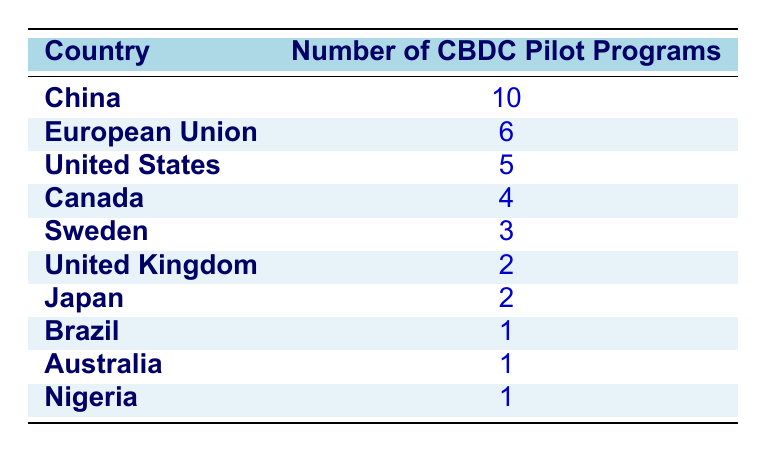What country has the most CBDC pilot programs? From the table, we can see that China has 10 pilot programs, which is the highest number listed.
Answer: China How many countries have more than 2 CBDC pilot programs? The countries with more than 2 pilot programs are China (10), European Union (6), and United States (5), totaling 3 countries.
Answer: 3 Does Canada have more CBDC pilot programs than Japan? Canada has 4 pilot programs and Japan has 2 pilot programs. Therefore, Canada does indeed have more pilot programs than Japan.
Answer: Yes What is the total number of CBDC pilot programs across all listed countries? To find the total, we sum the number of pilot programs: 10 (China) + 5 (United States) + 6 (European Union) + 4 (Canada) + 3 (Sweden) + 2 (United Kingdom) + 2 (Japan) + 1 (Brazil) + 1 (Australia) + 1 (Nigeria) = 35.
Answer: 35 Which country has the least number of CBDC pilot programs? Looking at the table, Brazil, Australia, and Nigeria each have 1 pilot program, making them the countries with the least number of pilot programs.
Answer: Brazil, Australia, Nigeria 